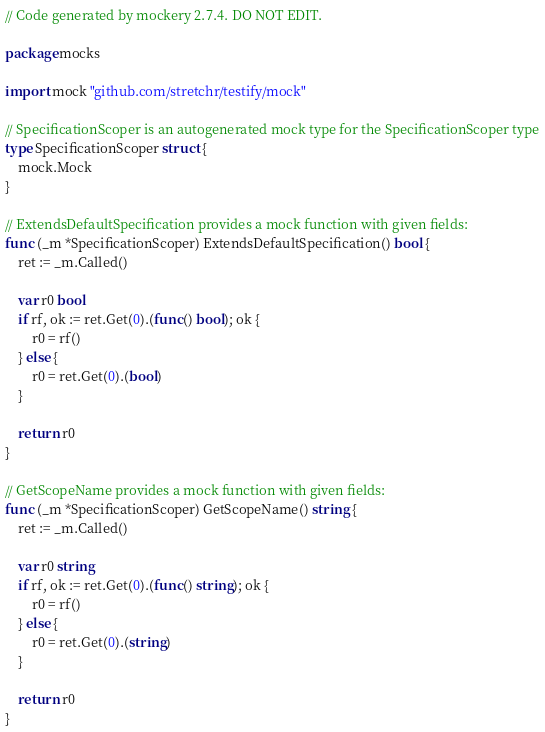<code> <loc_0><loc_0><loc_500><loc_500><_Go_>// Code generated by mockery 2.7.4. DO NOT EDIT.

package mocks

import mock "github.com/stretchr/testify/mock"

// SpecificationScoper is an autogenerated mock type for the SpecificationScoper type
type SpecificationScoper struct {
	mock.Mock
}

// ExtendsDefaultSpecification provides a mock function with given fields:
func (_m *SpecificationScoper) ExtendsDefaultSpecification() bool {
	ret := _m.Called()

	var r0 bool
	if rf, ok := ret.Get(0).(func() bool); ok {
		r0 = rf()
	} else {
		r0 = ret.Get(0).(bool)
	}

	return r0
}

// GetScopeName provides a mock function with given fields:
func (_m *SpecificationScoper) GetScopeName() string {
	ret := _m.Called()

	var r0 string
	if rf, ok := ret.Get(0).(func() string); ok {
		r0 = rf()
	} else {
		r0 = ret.Get(0).(string)
	}

	return r0
}
</code> 